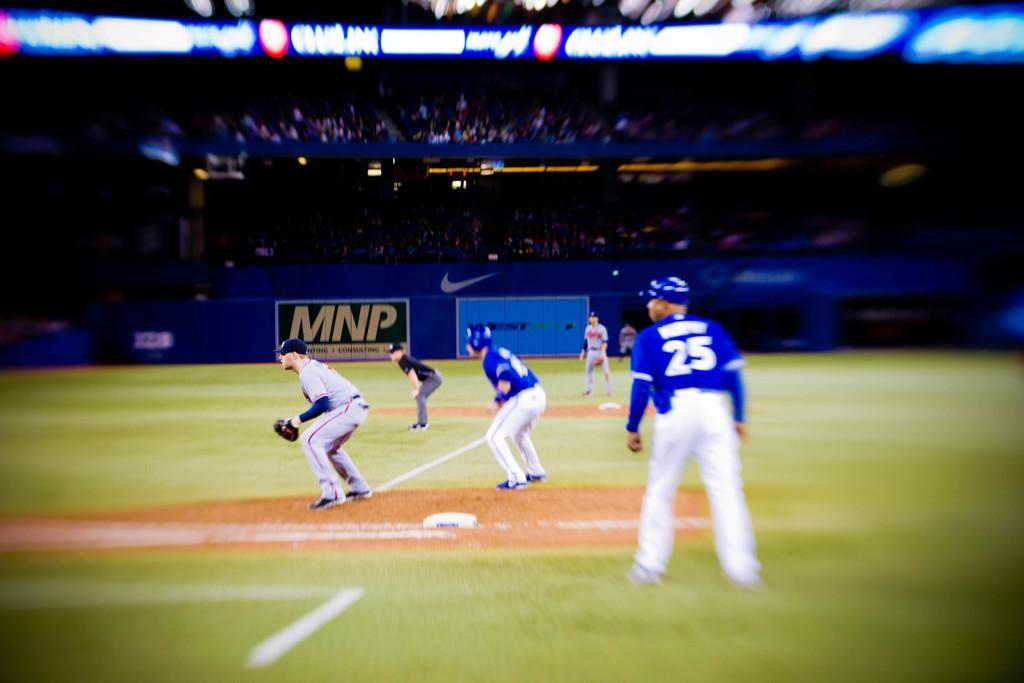<image>
Present a compact description of the photo's key features. Baseball players on the field with an advertising sign in the background for MNP. 